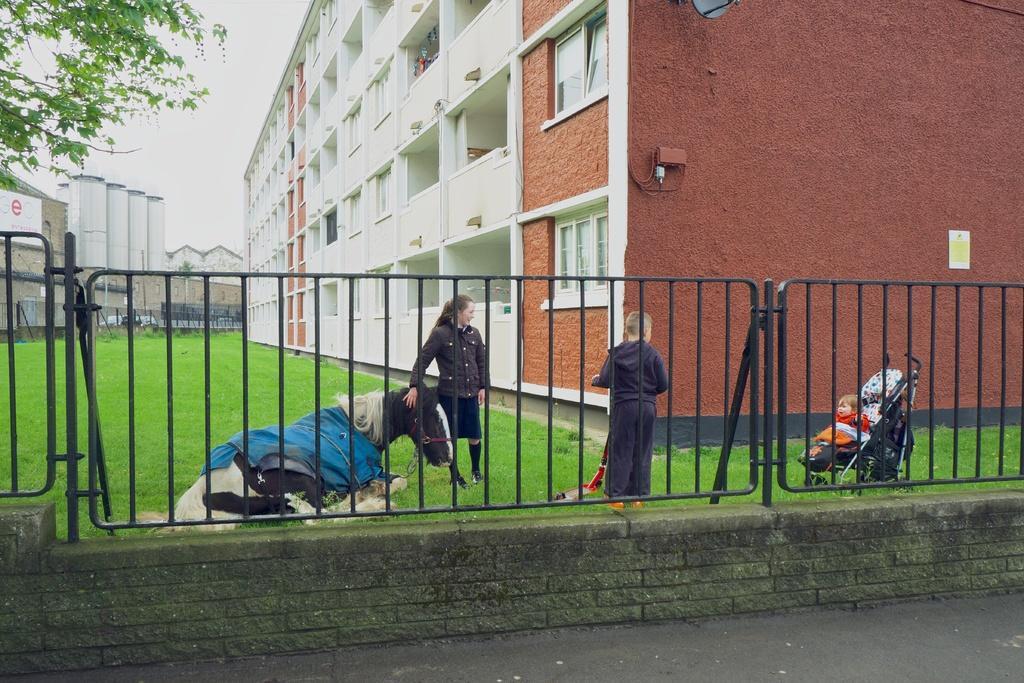In one or two sentences, can you explain what this image depicts? At the bottom we can see road and fence. In the background there are buildings,windows,some objects on the wall and on the left we can see a hoarding,tree,fence,buildings and sky. There is a woman and a person holding an object in the hands are standing on the ground and there is a horse sitting on the horse and a kid sitting on the stroller on the ground. 